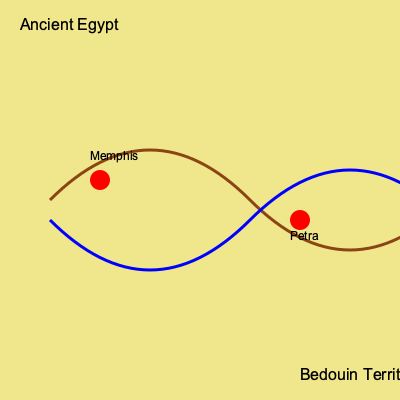Based on the map, which trade route characteristic is shared by both Ancient Egyptian and Bedouin paths, and how might this have facilitated cultural exchange? To answer this question, let's analyze the map step-by-step:

1. The map shows two distinct trade routes:
   - A brown route representing Ancient Egyptian trade paths
   - A blue route representing Bedouin trade paths

2. Both routes share a similar curved pattern, indicating they follow natural geographical features, likely avoiding harsh desert terrain.

3. The routes intersect at two points, marked by red circles. These represent important trade cities:
   - Memphis in Ancient Egypt
   - Petra in Bedouin territory

4. The shared characteristic of both routes is their curvature and intersection points. This suggests that:
   a) Both civilizations adapted their trade routes to similar geographical constraints.
   b) They utilized common oasis points or water sources along the way.

5. The intersection of these routes at major cities would have facilitated cultural exchange by:
   a) Providing meeting points for traders from both cultures
   b) Allowing for the exchange of goods, ideas, and technologies
   c) Potentially leading to the development of shared trading practices or languages

6. The similarity in route patterns suggests a shared understanding of efficient desert travel, which could have led to cultural similarities in navigation techniques and trading customs.

Therefore, the shared characteristic of curved routes with common intersection points would have significantly facilitated cultural exchange between Ancient Egyptians and Bedouins by creating natural meeting places for trade and interaction.
Answer: Curved routes with common intersection points 